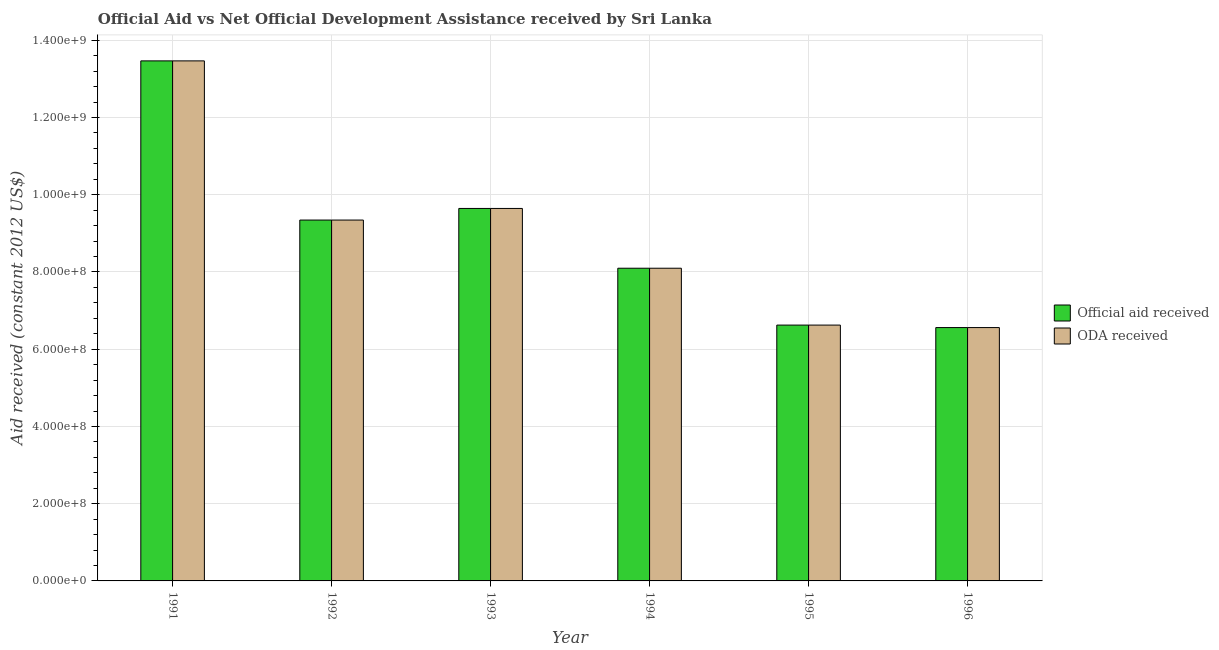Are the number of bars on each tick of the X-axis equal?
Your response must be concise. Yes. How many bars are there on the 2nd tick from the left?
Keep it short and to the point. 2. How many bars are there on the 6th tick from the right?
Make the answer very short. 2. What is the oda received in 1993?
Keep it short and to the point. 9.65e+08. Across all years, what is the maximum oda received?
Ensure brevity in your answer.  1.35e+09. Across all years, what is the minimum official aid received?
Make the answer very short. 6.56e+08. In which year was the oda received maximum?
Your response must be concise. 1991. What is the total oda received in the graph?
Give a very brief answer. 5.37e+09. What is the difference between the oda received in 1991 and that in 1993?
Provide a short and direct response. 3.82e+08. What is the difference between the oda received in 1996 and the official aid received in 1995?
Keep it short and to the point. -6.40e+06. What is the average oda received per year?
Offer a terse response. 8.96e+08. In the year 1992, what is the difference between the oda received and official aid received?
Give a very brief answer. 0. In how many years, is the oda received greater than 40000000 US$?
Offer a very short reply. 6. What is the ratio of the official aid received in 1991 to that in 1995?
Provide a short and direct response. 2.03. What is the difference between the highest and the second highest official aid received?
Offer a very short reply. 3.82e+08. What is the difference between the highest and the lowest oda received?
Keep it short and to the point. 6.91e+08. In how many years, is the oda received greater than the average oda received taken over all years?
Your response must be concise. 3. What does the 1st bar from the left in 1996 represents?
Keep it short and to the point. Official aid received. What does the 1st bar from the right in 1994 represents?
Provide a short and direct response. ODA received. Are all the bars in the graph horizontal?
Your answer should be very brief. No. Are the values on the major ticks of Y-axis written in scientific E-notation?
Provide a succinct answer. Yes. Does the graph contain any zero values?
Your answer should be very brief. No. Does the graph contain grids?
Make the answer very short. Yes. Where does the legend appear in the graph?
Provide a short and direct response. Center right. How many legend labels are there?
Make the answer very short. 2. What is the title of the graph?
Give a very brief answer. Official Aid vs Net Official Development Assistance received by Sri Lanka . Does "From human activities" appear as one of the legend labels in the graph?
Offer a terse response. No. What is the label or title of the X-axis?
Ensure brevity in your answer.  Year. What is the label or title of the Y-axis?
Keep it short and to the point. Aid received (constant 2012 US$). What is the Aid received (constant 2012 US$) of Official aid received in 1991?
Offer a terse response. 1.35e+09. What is the Aid received (constant 2012 US$) in ODA received in 1991?
Offer a very short reply. 1.35e+09. What is the Aid received (constant 2012 US$) in Official aid received in 1992?
Provide a succinct answer. 9.34e+08. What is the Aid received (constant 2012 US$) of ODA received in 1992?
Make the answer very short. 9.34e+08. What is the Aid received (constant 2012 US$) in Official aid received in 1993?
Give a very brief answer. 9.65e+08. What is the Aid received (constant 2012 US$) in ODA received in 1993?
Keep it short and to the point. 9.65e+08. What is the Aid received (constant 2012 US$) in Official aid received in 1994?
Provide a short and direct response. 8.10e+08. What is the Aid received (constant 2012 US$) of ODA received in 1994?
Provide a short and direct response. 8.10e+08. What is the Aid received (constant 2012 US$) of Official aid received in 1995?
Your answer should be very brief. 6.62e+08. What is the Aid received (constant 2012 US$) of ODA received in 1995?
Provide a succinct answer. 6.62e+08. What is the Aid received (constant 2012 US$) of Official aid received in 1996?
Keep it short and to the point. 6.56e+08. What is the Aid received (constant 2012 US$) of ODA received in 1996?
Provide a short and direct response. 6.56e+08. Across all years, what is the maximum Aid received (constant 2012 US$) in Official aid received?
Offer a terse response. 1.35e+09. Across all years, what is the maximum Aid received (constant 2012 US$) in ODA received?
Provide a succinct answer. 1.35e+09. Across all years, what is the minimum Aid received (constant 2012 US$) of Official aid received?
Your answer should be very brief. 6.56e+08. Across all years, what is the minimum Aid received (constant 2012 US$) in ODA received?
Your answer should be compact. 6.56e+08. What is the total Aid received (constant 2012 US$) in Official aid received in the graph?
Give a very brief answer. 5.37e+09. What is the total Aid received (constant 2012 US$) in ODA received in the graph?
Offer a terse response. 5.37e+09. What is the difference between the Aid received (constant 2012 US$) of Official aid received in 1991 and that in 1992?
Give a very brief answer. 4.12e+08. What is the difference between the Aid received (constant 2012 US$) of ODA received in 1991 and that in 1992?
Offer a terse response. 4.12e+08. What is the difference between the Aid received (constant 2012 US$) of Official aid received in 1991 and that in 1993?
Make the answer very short. 3.82e+08. What is the difference between the Aid received (constant 2012 US$) of ODA received in 1991 and that in 1993?
Offer a terse response. 3.82e+08. What is the difference between the Aid received (constant 2012 US$) of Official aid received in 1991 and that in 1994?
Ensure brevity in your answer.  5.37e+08. What is the difference between the Aid received (constant 2012 US$) in ODA received in 1991 and that in 1994?
Provide a short and direct response. 5.37e+08. What is the difference between the Aid received (constant 2012 US$) of Official aid received in 1991 and that in 1995?
Make the answer very short. 6.84e+08. What is the difference between the Aid received (constant 2012 US$) of ODA received in 1991 and that in 1995?
Provide a succinct answer. 6.84e+08. What is the difference between the Aid received (constant 2012 US$) in Official aid received in 1991 and that in 1996?
Your answer should be very brief. 6.91e+08. What is the difference between the Aid received (constant 2012 US$) of ODA received in 1991 and that in 1996?
Provide a short and direct response. 6.91e+08. What is the difference between the Aid received (constant 2012 US$) of Official aid received in 1992 and that in 1993?
Offer a terse response. -3.01e+07. What is the difference between the Aid received (constant 2012 US$) of ODA received in 1992 and that in 1993?
Provide a succinct answer. -3.01e+07. What is the difference between the Aid received (constant 2012 US$) of Official aid received in 1992 and that in 1994?
Provide a succinct answer. 1.25e+08. What is the difference between the Aid received (constant 2012 US$) in ODA received in 1992 and that in 1994?
Ensure brevity in your answer.  1.25e+08. What is the difference between the Aid received (constant 2012 US$) in Official aid received in 1992 and that in 1995?
Offer a terse response. 2.72e+08. What is the difference between the Aid received (constant 2012 US$) in ODA received in 1992 and that in 1995?
Your response must be concise. 2.72e+08. What is the difference between the Aid received (constant 2012 US$) of Official aid received in 1992 and that in 1996?
Offer a terse response. 2.78e+08. What is the difference between the Aid received (constant 2012 US$) in ODA received in 1992 and that in 1996?
Your response must be concise. 2.78e+08. What is the difference between the Aid received (constant 2012 US$) in Official aid received in 1993 and that in 1994?
Ensure brevity in your answer.  1.55e+08. What is the difference between the Aid received (constant 2012 US$) of ODA received in 1993 and that in 1994?
Offer a very short reply. 1.55e+08. What is the difference between the Aid received (constant 2012 US$) in Official aid received in 1993 and that in 1995?
Provide a succinct answer. 3.02e+08. What is the difference between the Aid received (constant 2012 US$) of ODA received in 1993 and that in 1995?
Keep it short and to the point. 3.02e+08. What is the difference between the Aid received (constant 2012 US$) in Official aid received in 1993 and that in 1996?
Your response must be concise. 3.08e+08. What is the difference between the Aid received (constant 2012 US$) in ODA received in 1993 and that in 1996?
Your response must be concise. 3.08e+08. What is the difference between the Aid received (constant 2012 US$) of Official aid received in 1994 and that in 1995?
Your answer should be very brief. 1.47e+08. What is the difference between the Aid received (constant 2012 US$) in ODA received in 1994 and that in 1995?
Your response must be concise. 1.47e+08. What is the difference between the Aid received (constant 2012 US$) in Official aid received in 1994 and that in 1996?
Give a very brief answer. 1.54e+08. What is the difference between the Aid received (constant 2012 US$) of ODA received in 1994 and that in 1996?
Ensure brevity in your answer.  1.54e+08. What is the difference between the Aid received (constant 2012 US$) in Official aid received in 1995 and that in 1996?
Ensure brevity in your answer.  6.40e+06. What is the difference between the Aid received (constant 2012 US$) of ODA received in 1995 and that in 1996?
Offer a terse response. 6.40e+06. What is the difference between the Aid received (constant 2012 US$) of Official aid received in 1991 and the Aid received (constant 2012 US$) of ODA received in 1992?
Provide a short and direct response. 4.12e+08. What is the difference between the Aid received (constant 2012 US$) in Official aid received in 1991 and the Aid received (constant 2012 US$) in ODA received in 1993?
Ensure brevity in your answer.  3.82e+08. What is the difference between the Aid received (constant 2012 US$) of Official aid received in 1991 and the Aid received (constant 2012 US$) of ODA received in 1994?
Provide a succinct answer. 5.37e+08. What is the difference between the Aid received (constant 2012 US$) in Official aid received in 1991 and the Aid received (constant 2012 US$) in ODA received in 1995?
Offer a very short reply. 6.84e+08. What is the difference between the Aid received (constant 2012 US$) of Official aid received in 1991 and the Aid received (constant 2012 US$) of ODA received in 1996?
Give a very brief answer. 6.91e+08. What is the difference between the Aid received (constant 2012 US$) of Official aid received in 1992 and the Aid received (constant 2012 US$) of ODA received in 1993?
Your answer should be compact. -3.01e+07. What is the difference between the Aid received (constant 2012 US$) of Official aid received in 1992 and the Aid received (constant 2012 US$) of ODA received in 1994?
Offer a very short reply. 1.25e+08. What is the difference between the Aid received (constant 2012 US$) in Official aid received in 1992 and the Aid received (constant 2012 US$) in ODA received in 1995?
Offer a terse response. 2.72e+08. What is the difference between the Aid received (constant 2012 US$) in Official aid received in 1992 and the Aid received (constant 2012 US$) in ODA received in 1996?
Provide a succinct answer. 2.78e+08. What is the difference between the Aid received (constant 2012 US$) of Official aid received in 1993 and the Aid received (constant 2012 US$) of ODA received in 1994?
Ensure brevity in your answer.  1.55e+08. What is the difference between the Aid received (constant 2012 US$) in Official aid received in 1993 and the Aid received (constant 2012 US$) in ODA received in 1995?
Ensure brevity in your answer.  3.02e+08. What is the difference between the Aid received (constant 2012 US$) of Official aid received in 1993 and the Aid received (constant 2012 US$) of ODA received in 1996?
Your response must be concise. 3.08e+08. What is the difference between the Aid received (constant 2012 US$) of Official aid received in 1994 and the Aid received (constant 2012 US$) of ODA received in 1995?
Your response must be concise. 1.47e+08. What is the difference between the Aid received (constant 2012 US$) in Official aid received in 1994 and the Aid received (constant 2012 US$) in ODA received in 1996?
Offer a terse response. 1.54e+08. What is the difference between the Aid received (constant 2012 US$) in Official aid received in 1995 and the Aid received (constant 2012 US$) in ODA received in 1996?
Offer a terse response. 6.40e+06. What is the average Aid received (constant 2012 US$) of Official aid received per year?
Keep it short and to the point. 8.96e+08. What is the average Aid received (constant 2012 US$) of ODA received per year?
Keep it short and to the point. 8.96e+08. In the year 1991, what is the difference between the Aid received (constant 2012 US$) of Official aid received and Aid received (constant 2012 US$) of ODA received?
Your answer should be compact. 0. In the year 1992, what is the difference between the Aid received (constant 2012 US$) of Official aid received and Aid received (constant 2012 US$) of ODA received?
Ensure brevity in your answer.  0. What is the ratio of the Aid received (constant 2012 US$) of Official aid received in 1991 to that in 1992?
Offer a very short reply. 1.44. What is the ratio of the Aid received (constant 2012 US$) of ODA received in 1991 to that in 1992?
Give a very brief answer. 1.44. What is the ratio of the Aid received (constant 2012 US$) of Official aid received in 1991 to that in 1993?
Your answer should be very brief. 1.4. What is the ratio of the Aid received (constant 2012 US$) of ODA received in 1991 to that in 1993?
Offer a very short reply. 1.4. What is the ratio of the Aid received (constant 2012 US$) of Official aid received in 1991 to that in 1994?
Offer a terse response. 1.66. What is the ratio of the Aid received (constant 2012 US$) of ODA received in 1991 to that in 1994?
Ensure brevity in your answer.  1.66. What is the ratio of the Aid received (constant 2012 US$) in Official aid received in 1991 to that in 1995?
Give a very brief answer. 2.03. What is the ratio of the Aid received (constant 2012 US$) in ODA received in 1991 to that in 1995?
Offer a very short reply. 2.03. What is the ratio of the Aid received (constant 2012 US$) in Official aid received in 1991 to that in 1996?
Provide a succinct answer. 2.05. What is the ratio of the Aid received (constant 2012 US$) in ODA received in 1991 to that in 1996?
Provide a short and direct response. 2.05. What is the ratio of the Aid received (constant 2012 US$) of Official aid received in 1992 to that in 1993?
Make the answer very short. 0.97. What is the ratio of the Aid received (constant 2012 US$) of ODA received in 1992 to that in 1993?
Keep it short and to the point. 0.97. What is the ratio of the Aid received (constant 2012 US$) of Official aid received in 1992 to that in 1994?
Your answer should be compact. 1.15. What is the ratio of the Aid received (constant 2012 US$) of ODA received in 1992 to that in 1994?
Ensure brevity in your answer.  1.15. What is the ratio of the Aid received (constant 2012 US$) of Official aid received in 1992 to that in 1995?
Your answer should be very brief. 1.41. What is the ratio of the Aid received (constant 2012 US$) of ODA received in 1992 to that in 1995?
Provide a succinct answer. 1.41. What is the ratio of the Aid received (constant 2012 US$) in Official aid received in 1992 to that in 1996?
Your answer should be compact. 1.42. What is the ratio of the Aid received (constant 2012 US$) in ODA received in 1992 to that in 1996?
Your answer should be compact. 1.42. What is the ratio of the Aid received (constant 2012 US$) of Official aid received in 1993 to that in 1994?
Your answer should be compact. 1.19. What is the ratio of the Aid received (constant 2012 US$) in ODA received in 1993 to that in 1994?
Your response must be concise. 1.19. What is the ratio of the Aid received (constant 2012 US$) of Official aid received in 1993 to that in 1995?
Your answer should be compact. 1.46. What is the ratio of the Aid received (constant 2012 US$) in ODA received in 1993 to that in 1995?
Provide a succinct answer. 1.46. What is the ratio of the Aid received (constant 2012 US$) of Official aid received in 1993 to that in 1996?
Provide a succinct answer. 1.47. What is the ratio of the Aid received (constant 2012 US$) of ODA received in 1993 to that in 1996?
Ensure brevity in your answer.  1.47. What is the ratio of the Aid received (constant 2012 US$) of Official aid received in 1994 to that in 1995?
Offer a terse response. 1.22. What is the ratio of the Aid received (constant 2012 US$) of ODA received in 1994 to that in 1995?
Provide a succinct answer. 1.22. What is the ratio of the Aid received (constant 2012 US$) in Official aid received in 1994 to that in 1996?
Your response must be concise. 1.23. What is the ratio of the Aid received (constant 2012 US$) in ODA received in 1994 to that in 1996?
Ensure brevity in your answer.  1.23. What is the ratio of the Aid received (constant 2012 US$) of Official aid received in 1995 to that in 1996?
Your answer should be very brief. 1.01. What is the ratio of the Aid received (constant 2012 US$) in ODA received in 1995 to that in 1996?
Provide a succinct answer. 1.01. What is the difference between the highest and the second highest Aid received (constant 2012 US$) in Official aid received?
Offer a very short reply. 3.82e+08. What is the difference between the highest and the second highest Aid received (constant 2012 US$) in ODA received?
Your answer should be very brief. 3.82e+08. What is the difference between the highest and the lowest Aid received (constant 2012 US$) of Official aid received?
Ensure brevity in your answer.  6.91e+08. What is the difference between the highest and the lowest Aid received (constant 2012 US$) in ODA received?
Offer a terse response. 6.91e+08. 